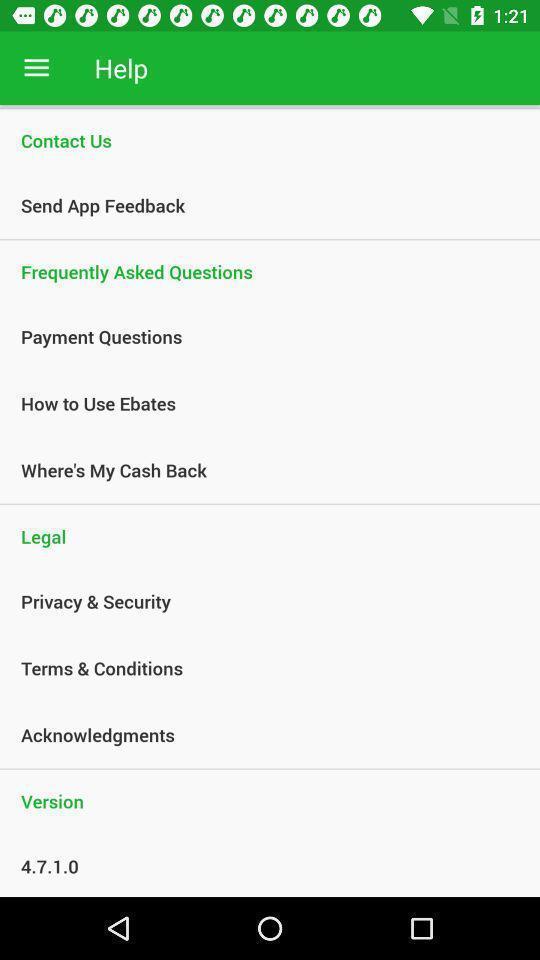Provide a textual representation of this image. Screen shows about help desk center. 